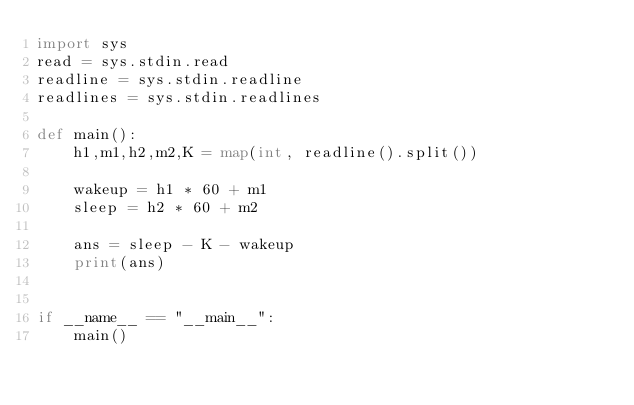<code> <loc_0><loc_0><loc_500><loc_500><_Python_>import sys
read = sys.stdin.read
readline = sys.stdin.readline
readlines = sys.stdin.readlines

def main():
    h1,m1,h2,m2,K = map(int, readline().split())

    wakeup = h1 * 60 + m1
    sleep = h2 * 60 + m2

    ans = sleep - K - wakeup
    print(ans)


if __name__ == "__main__":
    main()
</code> 